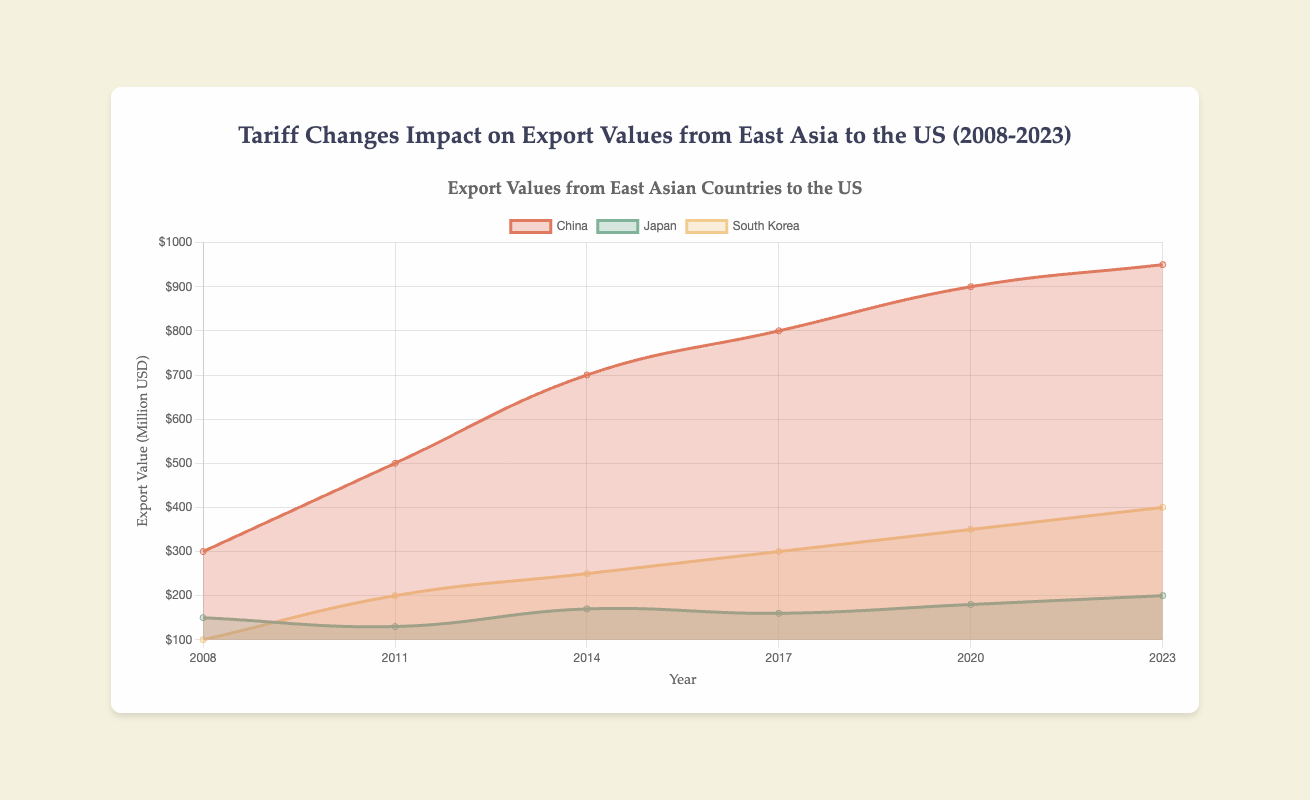Which country had the highest export value to the US in 2008? China had an export value of $300 million, Japan had $150 million, and South Korea had $100 million. The highest value is $300 million from China.
Answer: China How did the export value from China change from 2011 to 2017? In 2011, the export value from China was $500 million. By 2017, it had increased to $800 million. The change is $800 million - $500 million = $300 million.
Answer: Increased by $300 million What is the difference in export values between Japan and South Korea for the year 2023? In 2023, Japan's export value was $200 million, and South Korea's was $400 million. The difference is $400 million - $200 million = $200 million.
Answer: $200 million Which country experienced the largest proportional change in tariff from 2008 to 2023? China had a tariff change from 10 in 2008 to -10 in 2023, a change of -20. Japan's change was from 8 in 2008 to 5 in 2023, which is -3. South Korea changed from 12 in 2008 to -5 in 2023, which is -17. The largest is from China.
Answer: China What is the average export value for South Korea across all the given years? The values are $100 million (2008), $200 million (2011), $250 million (2014), $300 million (2017), $350 million (2020), and $400 million (2023). The average is ($100+$200+$250+$300+$350+$400) / 6 = $1600 million / 6 ≈ $267 million.
Answer: $267 million Compare the tariff change trends between China and Japan from 2008 to 2023. China had tariff changes of 10 (2008), 5 (2011), 2 (2014), -7 (2017), 15 (2020), -10 (2023). Japan had changes of 8 (2008), -3 (2011), 0 (2014), 4 (2017), -6 (2020), 5 (2023). Both countries show fluctuations but Japan’s changes are less extreme.
Answer: Fluctuations for both, Japan less extreme Which year did South Korea have the highest export value to the US and how much was it? Checking the South Korean export values: $100 million (2008), $200 million (2011), $250 million (2014), $300 million (2017), $350 million (2020), $400 million (2023). The highest is $400 million in 2023.
Answer: 2023, $400 million What is the overall trend in export values from East Asia to the US from 2008 to 2023? Considering all values, there is a general increase in export values for all countries, despite fluctuations in individual years. This indicates an overall rising trend.
Answer: Rising trend Which country showed a negative tariff change in 2020 and what was its corresponding export value that year? Only Japan showed a negative tariff change of -6 in 2020, with an export value of $180 million.
Answer: Japan, $180 million 